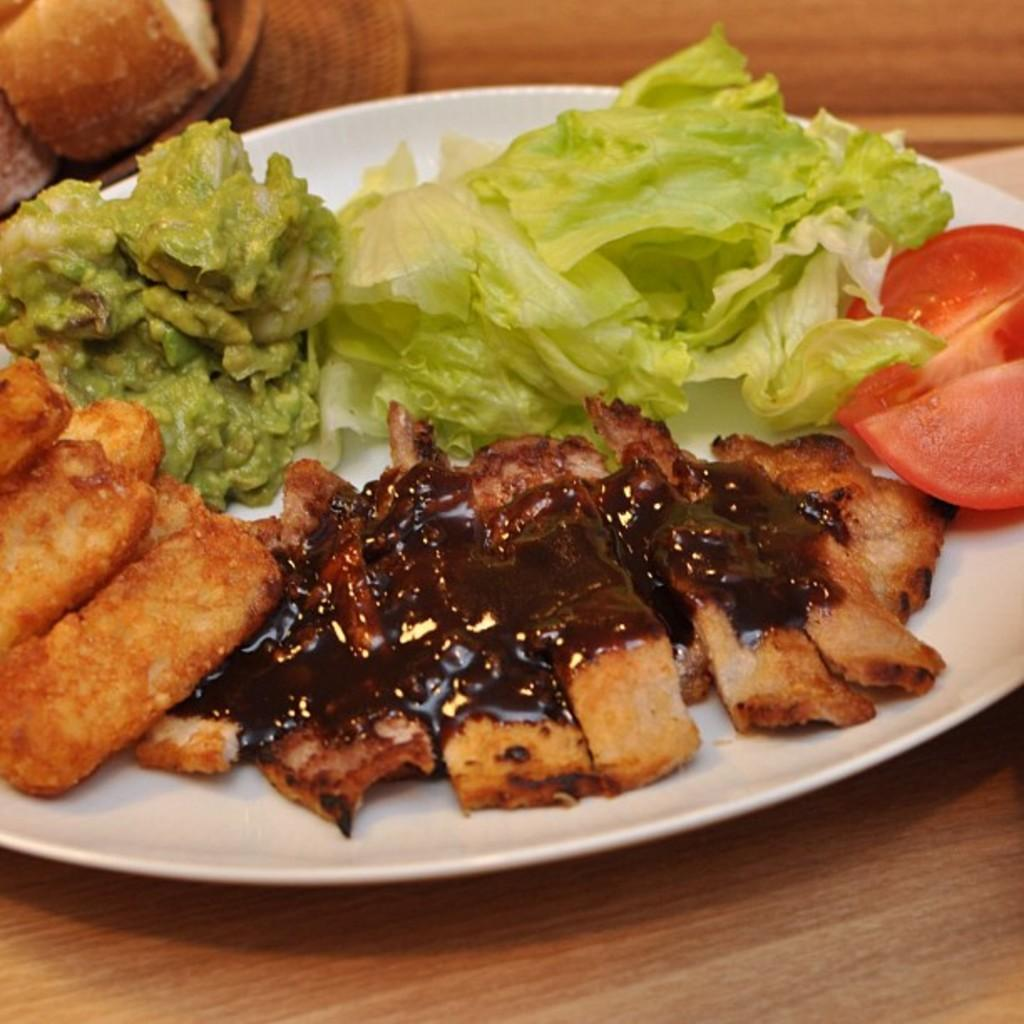What is on the plate that is visible in the image? There is a plate with food items in the image. Where is the plate located in the image? The plate is on a table in the image. Can you describe the food items on the plate? Unfortunately, the specific food items cannot be determined from the provided facts. Are there any other plates with food items visible in the image? Yes, there is another plate with food items in the background of the image. What type of straw is used to feed the hen in the image? There is no hen or straw present in the image. 